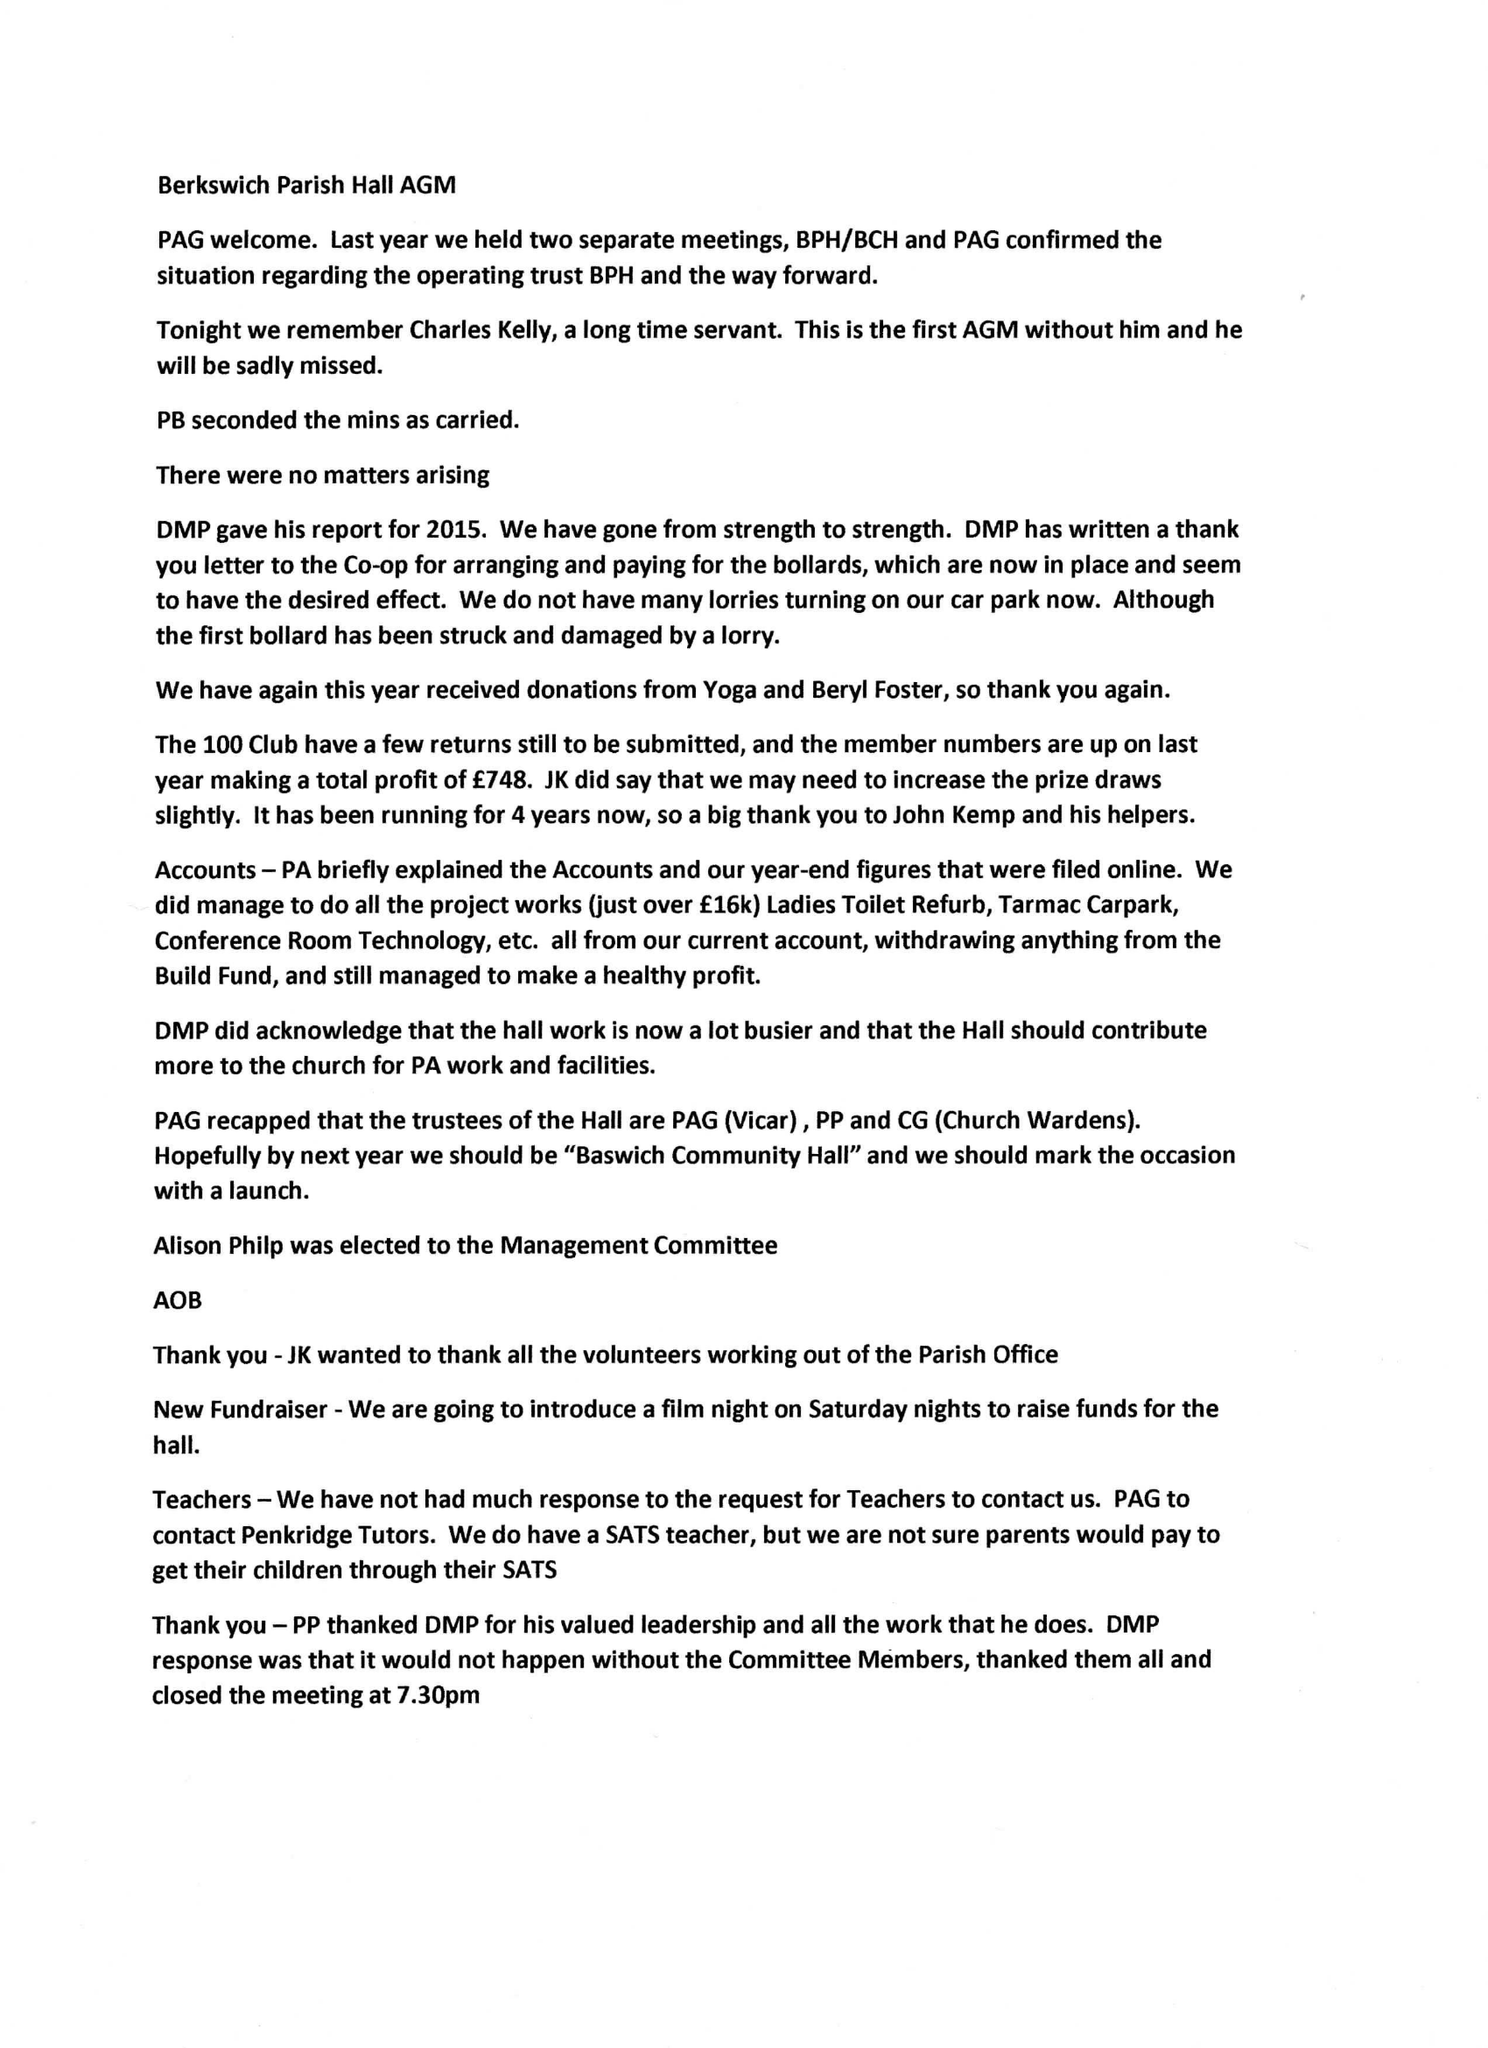What is the value for the address__street_line?
Answer the question using a single word or phrase. BASWICH LANE 